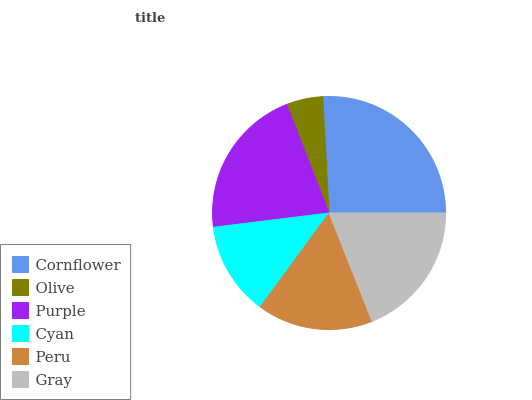Is Olive the minimum?
Answer yes or no. Yes. Is Cornflower the maximum?
Answer yes or no. Yes. Is Purple the minimum?
Answer yes or no. No. Is Purple the maximum?
Answer yes or no. No. Is Purple greater than Olive?
Answer yes or no. Yes. Is Olive less than Purple?
Answer yes or no. Yes. Is Olive greater than Purple?
Answer yes or no. No. Is Purple less than Olive?
Answer yes or no. No. Is Gray the high median?
Answer yes or no. Yes. Is Peru the low median?
Answer yes or no. Yes. Is Olive the high median?
Answer yes or no. No. Is Cornflower the low median?
Answer yes or no. No. 